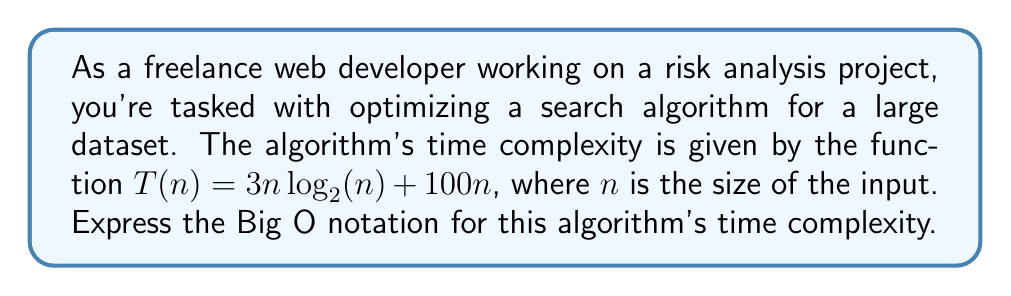Can you answer this question? To determine the Big O notation for the given time complexity function, we need to follow these steps:

1. Identify the terms in the function:
   $T(n) = 3n\log_2(n) + 100n$

2. Compare the growth rates of the terms:
   - $3n\log_2(n)$ grows faster than $100n$ for large values of $n$
   - The constant factor 3 doesn't affect the overall growth rate

3. Keep the term with the highest growth rate:
   $3n\log_2(n)$

4. Remove the constant factor:
   $n\log_2(n)$

5. Express in Big O notation:
   $O(n\log n)$

Note: In Big O notation, we typically omit the base of the logarithm since all logarithms are related by a constant factor, which doesn't affect the overall complexity class.

Therefore, the time complexity of the algorithm in Big O notation is $O(n\log n)$.
Answer: $O(n\log n)$ 